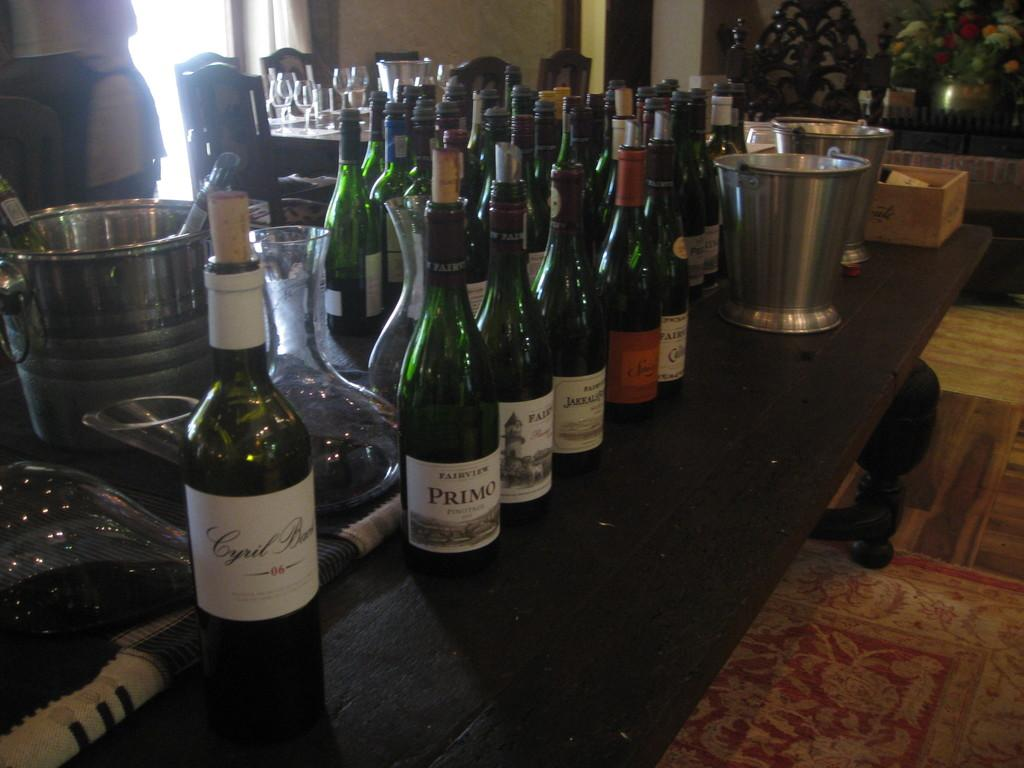<image>
Summarize the visual content of the image. Bottles of wine are on a bar and one of them is Primo. 